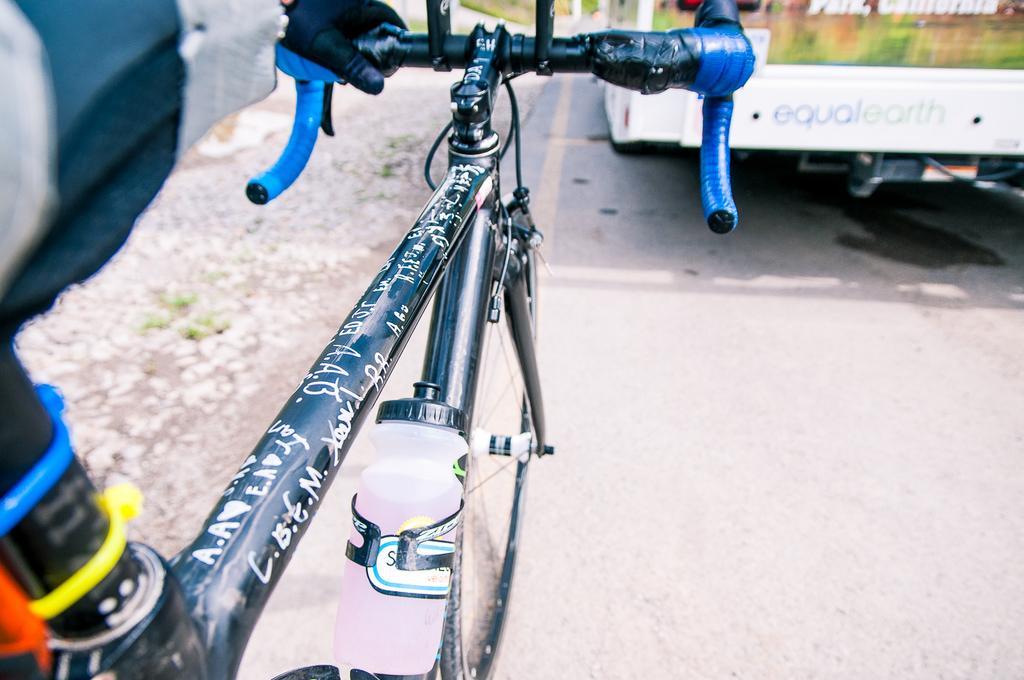Describe this image in one or two sentences. In the image there is a cycle with water bottle to it on the side of the road with a bus in front of it. 